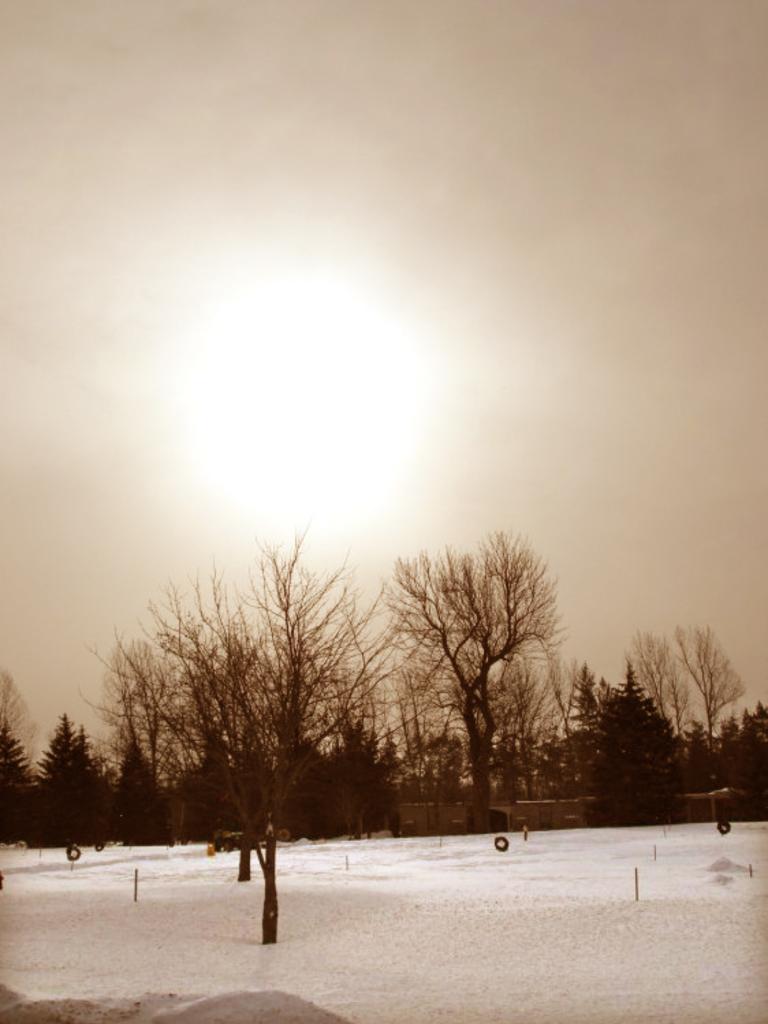How would you summarize this image in a sentence or two? At the bottom we can see snow on the ground and we can also see trees, poles, objects and houses. In the background we can see the sun in the sky. 